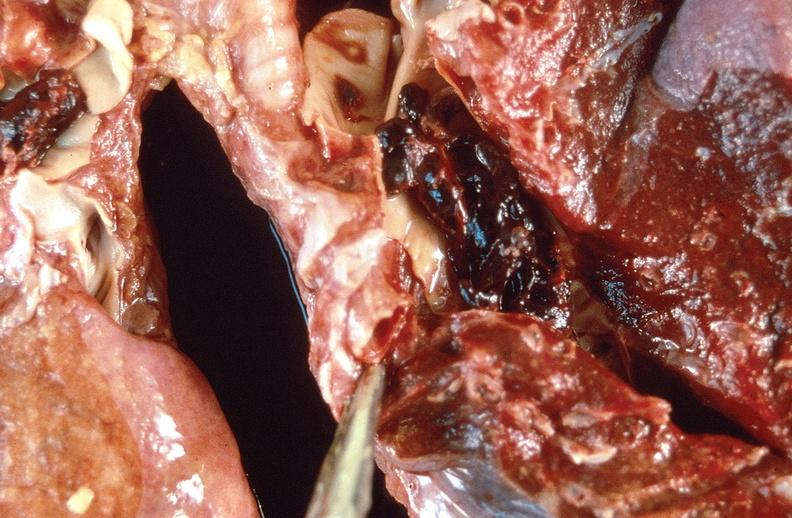does this image show pulmonary thromboemboli?
Answer the question using a single word or phrase. Yes 